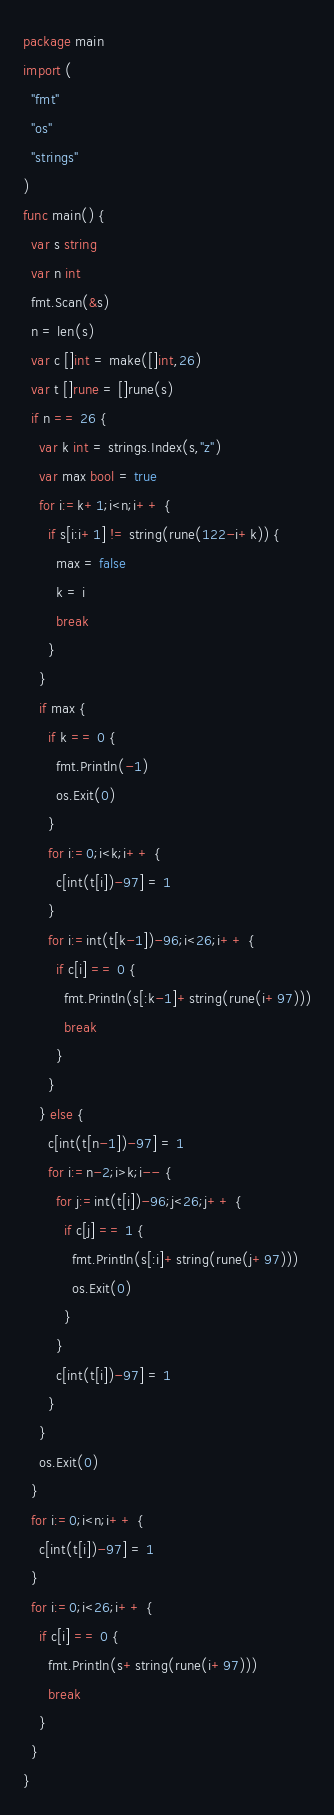<code> <loc_0><loc_0><loc_500><loc_500><_Go_>package main
import (
  "fmt"
  "os"
  "strings"
)
func main() {
  var s string
  var n int
  fmt.Scan(&s)
  n = len(s)
  var c []int = make([]int,26)
  var t []rune = []rune(s)
  if n == 26 {
    var k int = strings.Index(s,"z")
    var max bool = true
    for i:=k+1;i<n;i++ {
      if s[i:i+1] != string(rune(122-i+k)) {
        max = false
        k = i
        break
      }
    }
    if max {
      if k == 0 {
        fmt.Println(-1)
        os.Exit(0)
      }
      for i:=0;i<k;i++ {
        c[int(t[i])-97] = 1
      }
      for i:=int(t[k-1])-96;i<26;i++ {
        if c[i] == 0 {
          fmt.Println(s[:k-1]+string(rune(i+97)))
          break
        }
      }
    } else {
      c[int(t[n-1])-97] = 1
      for i:=n-2;i>k;i-- {
        for j:=int(t[i])-96;j<26;j++ {
          if c[j] == 1 {
            fmt.Println(s[:i]+string(rune(j+97)))
            os.Exit(0)
          }
        }
        c[int(t[i])-97] = 1
      }
    }
    os.Exit(0)
  }
  for i:=0;i<n;i++ {
    c[int(t[i])-97] = 1
  }
  for i:=0;i<26;i++ {
    if c[i] == 0 {
      fmt.Println(s+string(rune(i+97)))
      break
    }
  }
}</code> 